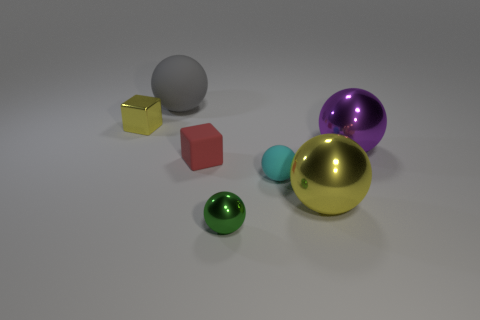Subtract all small green metallic spheres. How many spheres are left? 4 Subtract all yellow balls. How many balls are left? 4 Subtract all blocks. How many objects are left? 5 Subtract all yellow blocks. Subtract all cyan cylinders. How many blocks are left? 1 Subtract all blue balls. How many blue cubes are left? 0 Subtract all small shiny objects. Subtract all brown shiny spheres. How many objects are left? 5 Add 4 small cyan objects. How many small cyan objects are left? 5 Add 6 matte spheres. How many matte spheres exist? 8 Add 3 yellow metal objects. How many objects exist? 10 Subtract 1 yellow cubes. How many objects are left? 6 